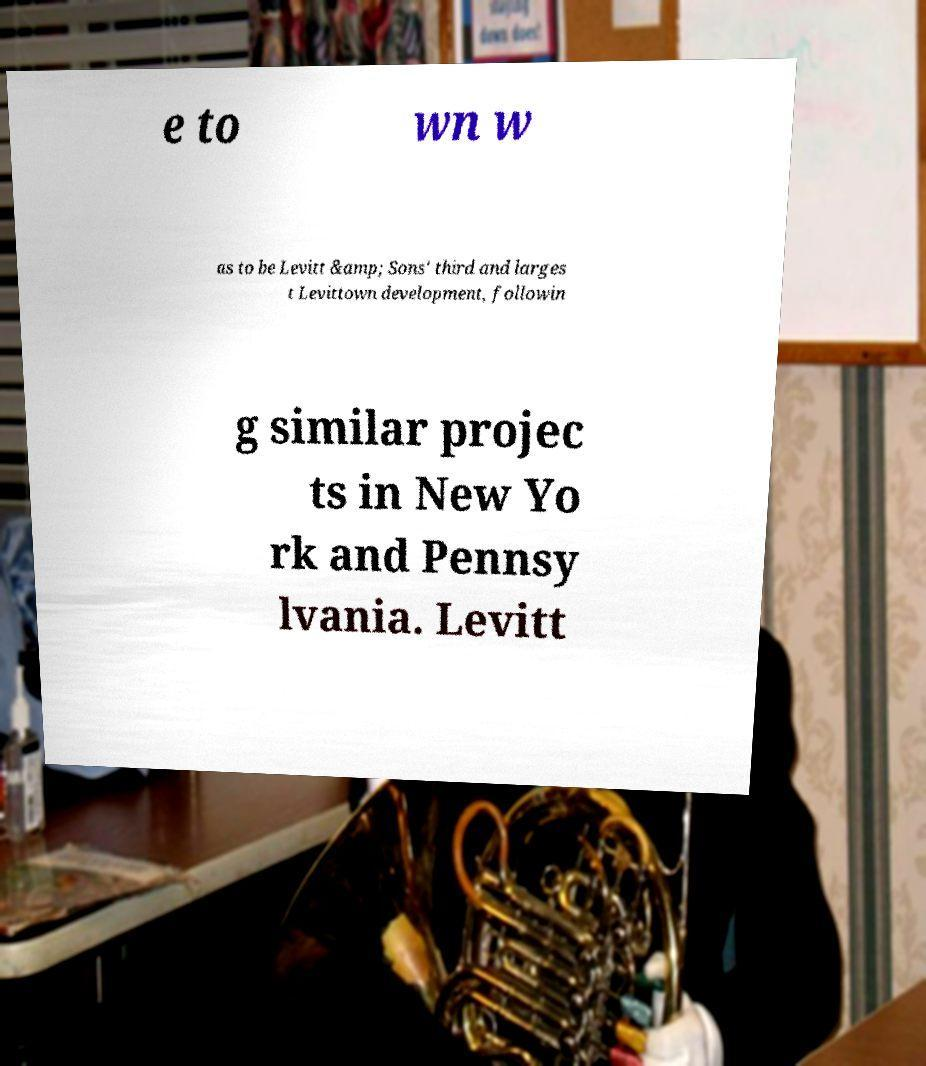Please read and relay the text visible in this image. What does it say? e to wn w as to be Levitt &amp; Sons' third and larges t Levittown development, followin g similar projec ts in New Yo rk and Pennsy lvania. Levitt 